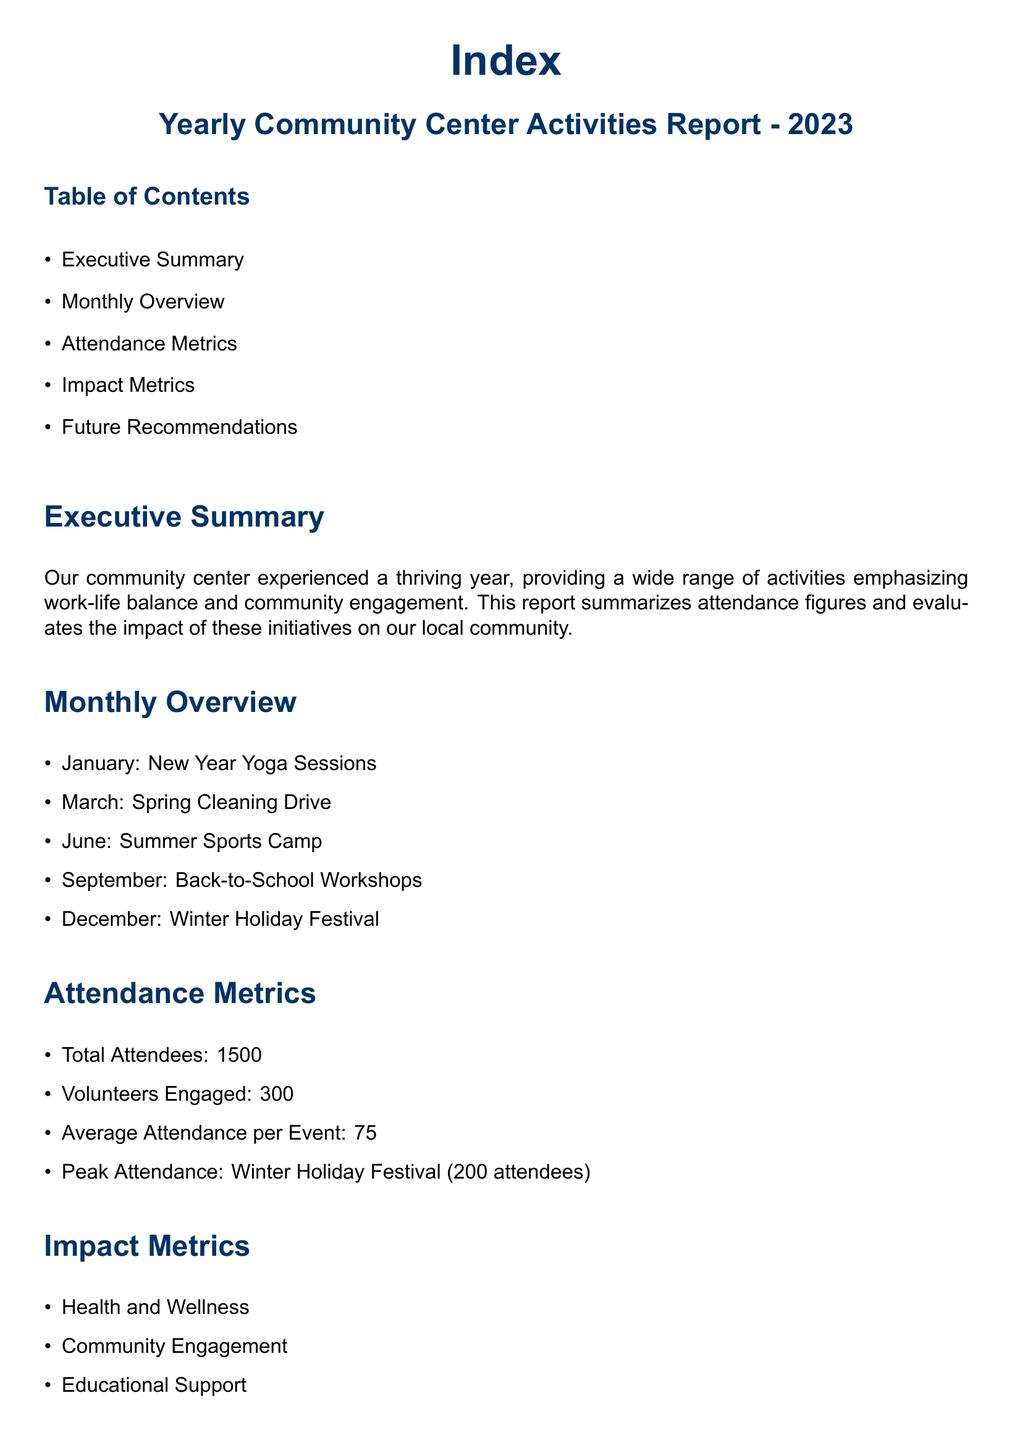What is the total number of attendees? The total number of attendees stated in the report is a specific metric provided under the Attendance Metrics section.
Answer: 1500 What was the peak attendance event? The report indicates that the peak attendance occurred during a specific event detailed in the Attendance Metrics section.
Answer: Winter Holiday Festival How many volunteers were engaged? The number of volunteers engaged is clearly stated within the Attendance Metrics section of the report.
Answer: 300 What was the average attendance per event? The average attendance per event is a direct metric provided under the Attendance Metrics section of the document.
Answer: 75 Which month featured the Winter Holiday Festival? The report outlines activities by month, and the Winter Holiday Festival is listed in one of those months.
Answer: December What are the three areas listed under Impact Metrics? The areas of impact are specified in the Impact Metrics section and summarize the evaluation of activities' effectiveness.
Answer: Health and Wellness, Community Engagement, Educational Support What is the focus of the community center as stated in the report? The report highlights the primary focus of the community center in a dedicated section towards the end of the document.
Answer: Work-Life Balance and Community Engagement What recommendation is made regarding younger demographics? Future Recommendations include suggestions for enhancing participation from specific groups, which is noted in that section.
Answer: Engagement of Younger Demographics 